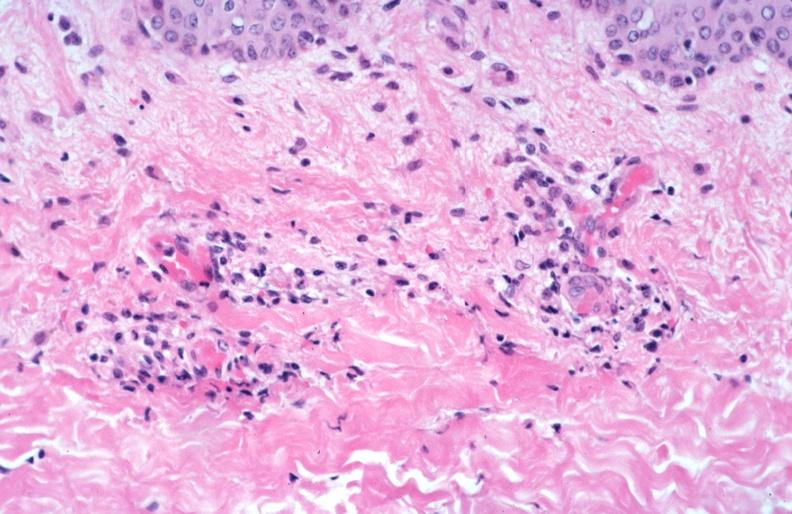does gross show skin?
Answer the question using a single word or phrase. No 